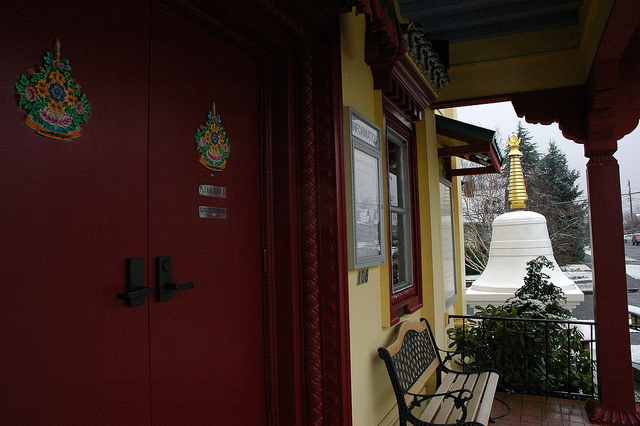<image>Where is the lampshade? I don't know where the lampshade is located. It may be on the porch or inside the house. Where is the lampshade? I don't know where the lampshade is. It can be seen on the porch or outside. 